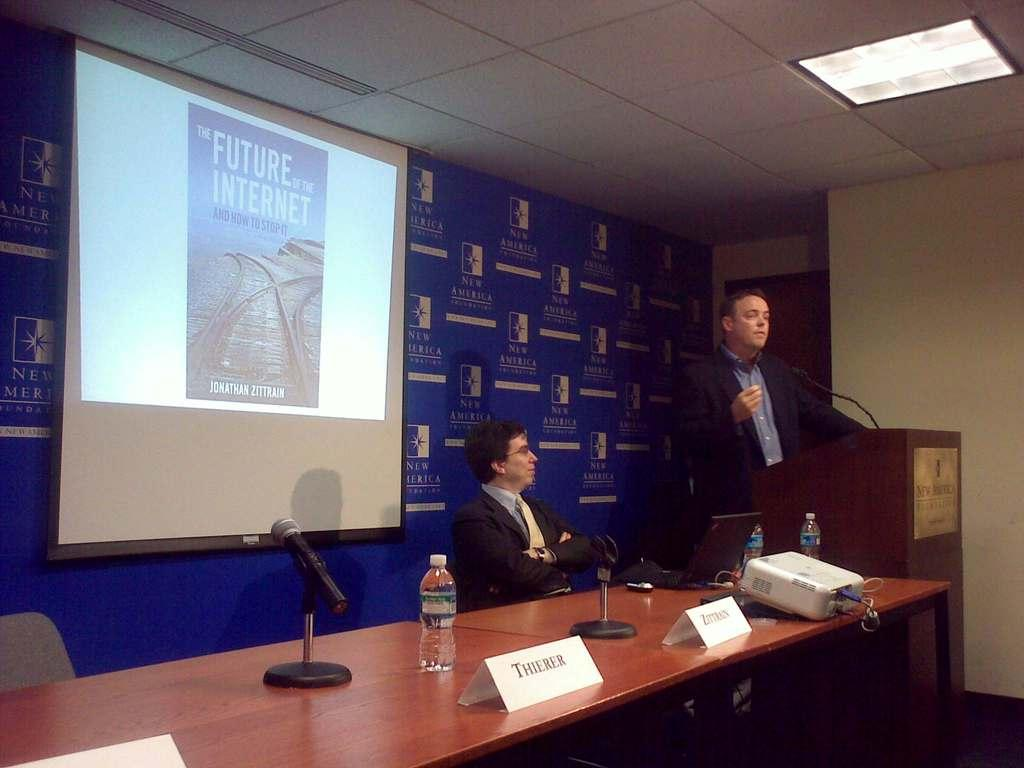<image>
Give a short and clear explanation of the subsequent image. A man behind a podium with a screen behind him showing a book called The Future of the Internet. 